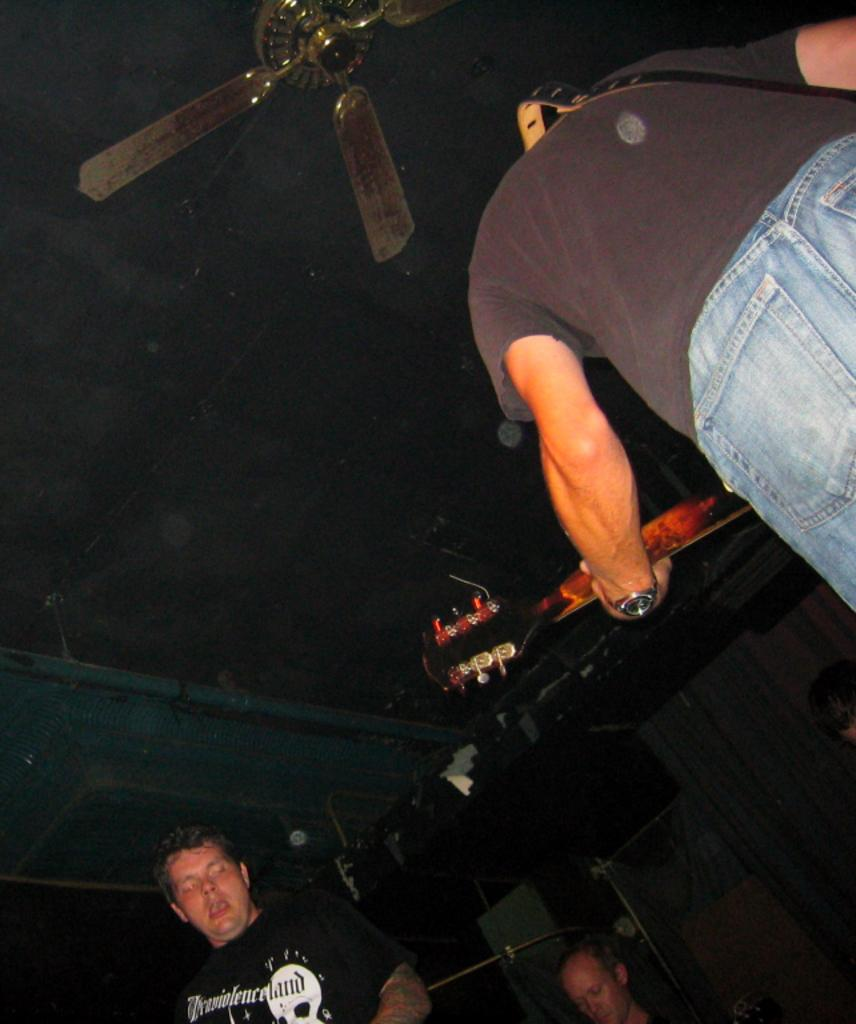What is the person in the image wearing? The person is wearing a black dress in the image. What is the person doing while wearing the black dress? The person is playing a guitar. Are there any other people in the image? Yes, there are two persons in front of the guitar player. What object can be seen in the image that might provide air circulation? There is a fan visible in the image. What type of beast can be seen interacting with the guitar player in the image? There is no beast present in the image; it features a person playing a guitar and two other people. How many birds are perched on the guitar in the image? There are no birds present in the image; it only features a person playing a guitar and two other people. 